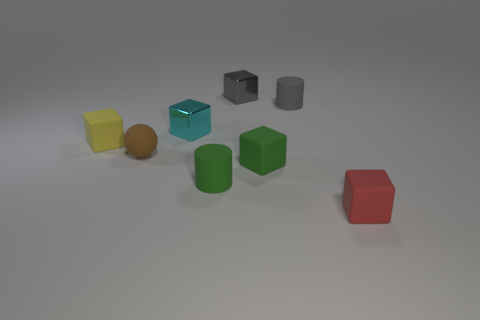Add 1 small matte cylinders. How many objects exist? 9 Subtract all tiny red matte blocks. How many blocks are left? 4 Subtract all gray blocks. How many blocks are left? 4 Subtract all small blue things. Subtract all cyan metallic things. How many objects are left? 7 Add 6 yellow objects. How many yellow objects are left? 7 Add 5 tiny gray matte cylinders. How many tiny gray matte cylinders exist? 6 Subtract 0 blue balls. How many objects are left? 8 Subtract all cubes. How many objects are left? 3 Subtract all purple balls. Subtract all purple cubes. How many balls are left? 1 Subtract all red balls. How many green cylinders are left? 1 